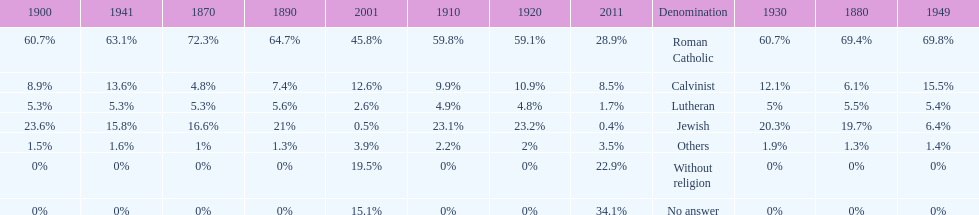Which denomination held the largest percentage in 1880? Roman Catholic. 